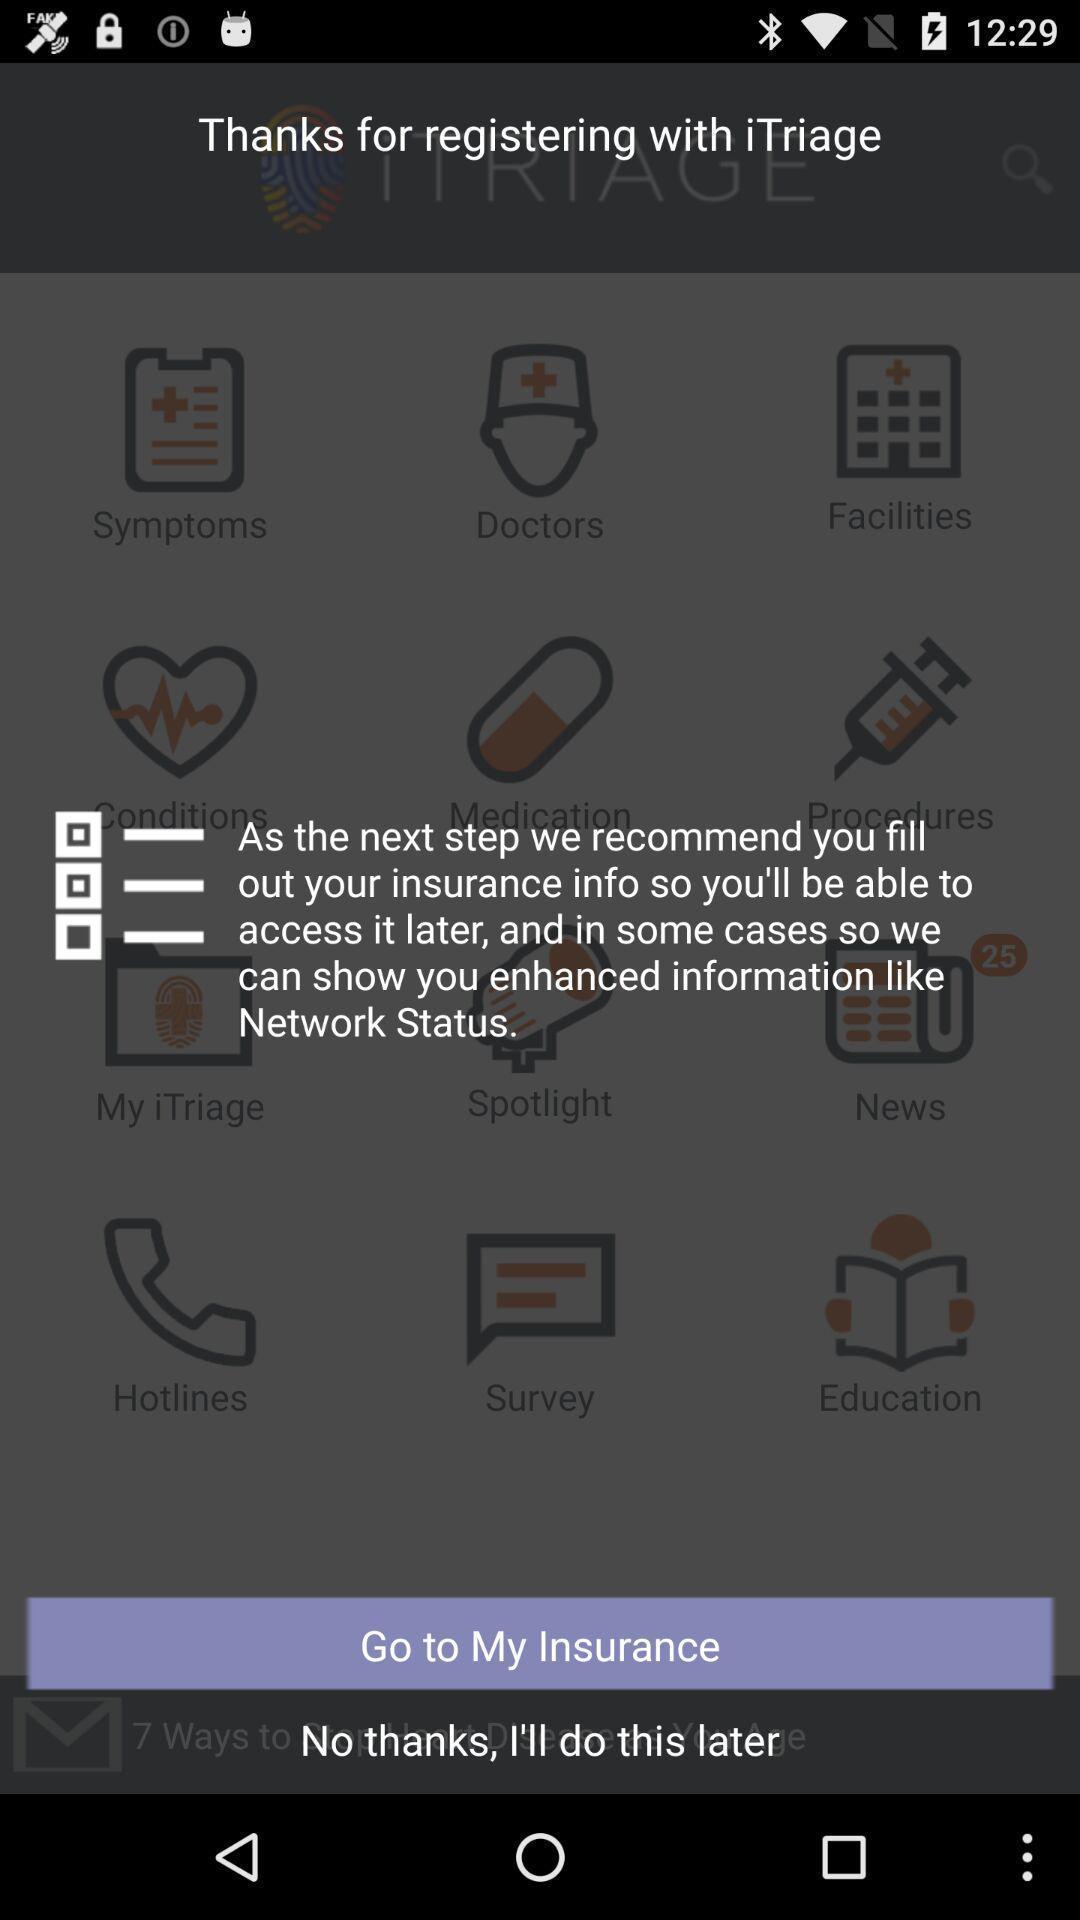Tell me about the visual elements in this screen capture. Pop up message. 